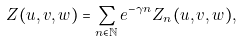Convert formula to latex. <formula><loc_0><loc_0><loc_500><loc_500>Z ( u , v , w ) = \sum _ { n \in \mathbb { N } } e ^ { - \gamma n } Z _ { n } ( u , v , w ) ,</formula> 